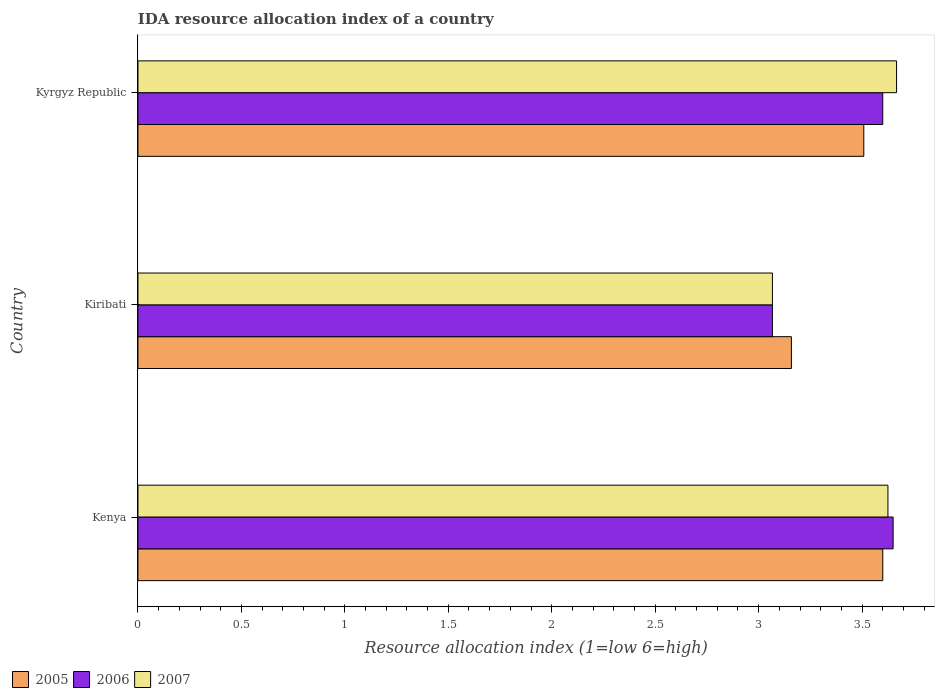How many different coloured bars are there?
Make the answer very short. 3. How many groups of bars are there?
Keep it short and to the point. 3. Are the number of bars per tick equal to the number of legend labels?
Offer a very short reply. Yes. Are the number of bars on each tick of the Y-axis equal?
Make the answer very short. Yes. How many bars are there on the 2nd tick from the bottom?
Offer a terse response. 3. What is the label of the 2nd group of bars from the top?
Your answer should be very brief. Kiribati. What is the IDA resource allocation index in 2007 in Kiribati?
Your answer should be compact. 3.07. Across all countries, what is the maximum IDA resource allocation index in 2006?
Give a very brief answer. 3.65. Across all countries, what is the minimum IDA resource allocation index in 2005?
Ensure brevity in your answer.  3.16. In which country was the IDA resource allocation index in 2006 maximum?
Give a very brief answer. Kenya. In which country was the IDA resource allocation index in 2007 minimum?
Ensure brevity in your answer.  Kiribati. What is the total IDA resource allocation index in 2007 in the graph?
Your response must be concise. 10.36. What is the difference between the IDA resource allocation index in 2005 in Kenya and that in Kiribati?
Make the answer very short. 0.44. What is the difference between the IDA resource allocation index in 2006 in Kenya and the IDA resource allocation index in 2007 in Kyrgyz Republic?
Keep it short and to the point. -0.02. What is the average IDA resource allocation index in 2007 per country?
Make the answer very short. 3.45. What is the difference between the IDA resource allocation index in 2006 and IDA resource allocation index in 2005 in Kenya?
Give a very brief answer. 0.05. What is the ratio of the IDA resource allocation index in 2007 in Kenya to that in Kiribati?
Make the answer very short. 1.18. Is the difference between the IDA resource allocation index in 2006 in Kenya and Kyrgyz Republic greater than the difference between the IDA resource allocation index in 2005 in Kenya and Kyrgyz Republic?
Ensure brevity in your answer.  No. What is the difference between the highest and the second highest IDA resource allocation index in 2006?
Your answer should be compact. 0.05. What is the difference between the highest and the lowest IDA resource allocation index in 2007?
Offer a terse response. 0.6. In how many countries, is the IDA resource allocation index in 2007 greater than the average IDA resource allocation index in 2007 taken over all countries?
Your response must be concise. 2. What does the 3rd bar from the top in Kiribati represents?
Offer a very short reply. 2005. Is it the case that in every country, the sum of the IDA resource allocation index in 2005 and IDA resource allocation index in 2007 is greater than the IDA resource allocation index in 2006?
Your response must be concise. Yes. Are all the bars in the graph horizontal?
Provide a succinct answer. Yes. How many countries are there in the graph?
Give a very brief answer. 3. What is the difference between two consecutive major ticks on the X-axis?
Provide a succinct answer. 0.5. Are the values on the major ticks of X-axis written in scientific E-notation?
Provide a short and direct response. No. Does the graph contain any zero values?
Your response must be concise. No. Where does the legend appear in the graph?
Offer a very short reply. Bottom left. How are the legend labels stacked?
Offer a very short reply. Horizontal. What is the title of the graph?
Provide a succinct answer. IDA resource allocation index of a country. What is the label or title of the X-axis?
Make the answer very short. Resource allocation index (1=low 6=high). What is the Resource allocation index (1=low 6=high) in 2006 in Kenya?
Keep it short and to the point. 3.65. What is the Resource allocation index (1=low 6=high) in 2007 in Kenya?
Keep it short and to the point. 3.62. What is the Resource allocation index (1=low 6=high) in 2005 in Kiribati?
Offer a terse response. 3.16. What is the Resource allocation index (1=low 6=high) of 2006 in Kiribati?
Offer a very short reply. 3.07. What is the Resource allocation index (1=low 6=high) in 2007 in Kiribati?
Your response must be concise. 3.07. What is the Resource allocation index (1=low 6=high) of 2005 in Kyrgyz Republic?
Give a very brief answer. 3.51. What is the Resource allocation index (1=low 6=high) in 2006 in Kyrgyz Republic?
Your response must be concise. 3.6. What is the Resource allocation index (1=low 6=high) in 2007 in Kyrgyz Republic?
Provide a short and direct response. 3.67. Across all countries, what is the maximum Resource allocation index (1=low 6=high) in 2006?
Keep it short and to the point. 3.65. Across all countries, what is the maximum Resource allocation index (1=low 6=high) of 2007?
Provide a short and direct response. 3.67. Across all countries, what is the minimum Resource allocation index (1=low 6=high) in 2005?
Keep it short and to the point. 3.16. Across all countries, what is the minimum Resource allocation index (1=low 6=high) of 2006?
Your response must be concise. 3.07. Across all countries, what is the minimum Resource allocation index (1=low 6=high) of 2007?
Give a very brief answer. 3.07. What is the total Resource allocation index (1=low 6=high) of 2005 in the graph?
Offer a very short reply. 10.27. What is the total Resource allocation index (1=low 6=high) in 2006 in the graph?
Provide a short and direct response. 10.32. What is the total Resource allocation index (1=low 6=high) of 2007 in the graph?
Make the answer very short. 10.36. What is the difference between the Resource allocation index (1=low 6=high) in 2005 in Kenya and that in Kiribati?
Ensure brevity in your answer.  0.44. What is the difference between the Resource allocation index (1=low 6=high) of 2006 in Kenya and that in Kiribati?
Offer a terse response. 0.58. What is the difference between the Resource allocation index (1=low 6=high) of 2007 in Kenya and that in Kiribati?
Offer a very short reply. 0.56. What is the difference between the Resource allocation index (1=low 6=high) in 2005 in Kenya and that in Kyrgyz Republic?
Keep it short and to the point. 0.09. What is the difference between the Resource allocation index (1=low 6=high) in 2007 in Kenya and that in Kyrgyz Republic?
Make the answer very short. -0.04. What is the difference between the Resource allocation index (1=low 6=high) of 2005 in Kiribati and that in Kyrgyz Republic?
Your answer should be compact. -0.35. What is the difference between the Resource allocation index (1=low 6=high) of 2006 in Kiribati and that in Kyrgyz Republic?
Your answer should be compact. -0.53. What is the difference between the Resource allocation index (1=low 6=high) in 2005 in Kenya and the Resource allocation index (1=low 6=high) in 2006 in Kiribati?
Your answer should be very brief. 0.53. What is the difference between the Resource allocation index (1=low 6=high) of 2005 in Kenya and the Resource allocation index (1=low 6=high) of 2007 in Kiribati?
Provide a succinct answer. 0.53. What is the difference between the Resource allocation index (1=low 6=high) of 2006 in Kenya and the Resource allocation index (1=low 6=high) of 2007 in Kiribati?
Offer a very short reply. 0.58. What is the difference between the Resource allocation index (1=low 6=high) of 2005 in Kenya and the Resource allocation index (1=low 6=high) of 2006 in Kyrgyz Republic?
Offer a terse response. 0. What is the difference between the Resource allocation index (1=low 6=high) of 2005 in Kenya and the Resource allocation index (1=low 6=high) of 2007 in Kyrgyz Republic?
Give a very brief answer. -0.07. What is the difference between the Resource allocation index (1=low 6=high) of 2006 in Kenya and the Resource allocation index (1=low 6=high) of 2007 in Kyrgyz Republic?
Provide a short and direct response. -0.02. What is the difference between the Resource allocation index (1=low 6=high) of 2005 in Kiribati and the Resource allocation index (1=low 6=high) of 2006 in Kyrgyz Republic?
Your answer should be compact. -0.44. What is the difference between the Resource allocation index (1=low 6=high) of 2005 in Kiribati and the Resource allocation index (1=low 6=high) of 2007 in Kyrgyz Republic?
Your response must be concise. -0.51. What is the average Resource allocation index (1=low 6=high) in 2005 per country?
Keep it short and to the point. 3.42. What is the average Resource allocation index (1=low 6=high) of 2006 per country?
Provide a succinct answer. 3.44. What is the average Resource allocation index (1=low 6=high) of 2007 per country?
Make the answer very short. 3.45. What is the difference between the Resource allocation index (1=low 6=high) of 2005 and Resource allocation index (1=low 6=high) of 2007 in Kenya?
Give a very brief answer. -0.03. What is the difference between the Resource allocation index (1=low 6=high) of 2006 and Resource allocation index (1=low 6=high) of 2007 in Kenya?
Your response must be concise. 0.03. What is the difference between the Resource allocation index (1=low 6=high) in 2005 and Resource allocation index (1=low 6=high) in 2006 in Kiribati?
Give a very brief answer. 0.09. What is the difference between the Resource allocation index (1=low 6=high) of 2005 and Resource allocation index (1=low 6=high) of 2007 in Kiribati?
Keep it short and to the point. 0.09. What is the difference between the Resource allocation index (1=low 6=high) in 2005 and Resource allocation index (1=low 6=high) in 2006 in Kyrgyz Republic?
Your answer should be very brief. -0.09. What is the difference between the Resource allocation index (1=low 6=high) of 2005 and Resource allocation index (1=low 6=high) of 2007 in Kyrgyz Republic?
Make the answer very short. -0.16. What is the difference between the Resource allocation index (1=low 6=high) of 2006 and Resource allocation index (1=low 6=high) of 2007 in Kyrgyz Republic?
Make the answer very short. -0.07. What is the ratio of the Resource allocation index (1=low 6=high) in 2005 in Kenya to that in Kiribati?
Ensure brevity in your answer.  1.14. What is the ratio of the Resource allocation index (1=low 6=high) in 2006 in Kenya to that in Kiribati?
Ensure brevity in your answer.  1.19. What is the ratio of the Resource allocation index (1=low 6=high) in 2007 in Kenya to that in Kiribati?
Offer a very short reply. 1.18. What is the ratio of the Resource allocation index (1=low 6=high) of 2005 in Kenya to that in Kyrgyz Republic?
Offer a terse response. 1.03. What is the ratio of the Resource allocation index (1=low 6=high) of 2006 in Kenya to that in Kyrgyz Republic?
Your answer should be very brief. 1.01. What is the ratio of the Resource allocation index (1=low 6=high) in 2005 in Kiribati to that in Kyrgyz Republic?
Make the answer very short. 0.9. What is the ratio of the Resource allocation index (1=low 6=high) of 2006 in Kiribati to that in Kyrgyz Republic?
Your answer should be compact. 0.85. What is the ratio of the Resource allocation index (1=low 6=high) of 2007 in Kiribati to that in Kyrgyz Republic?
Ensure brevity in your answer.  0.84. What is the difference between the highest and the second highest Resource allocation index (1=low 6=high) of 2005?
Keep it short and to the point. 0.09. What is the difference between the highest and the second highest Resource allocation index (1=low 6=high) in 2006?
Provide a succinct answer. 0.05. What is the difference between the highest and the second highest Resource allocation index (1=low 6=high) in 2007?
Your response must be concise. 0.04. What is the difference between the highest and the lowest Resource allocation index (1=low 6=high) in 2005?
Keep it short and to the point. 0.44. What is the difference between the highest and the lowest Resource allocation index (1=low 6=high) in 2006?
Your response must be concise. 0.58. What is the difference between the highest and the lowest Resource allocation index (1=low 6=high) in 2007?
Make the answer very short. 0.6. 